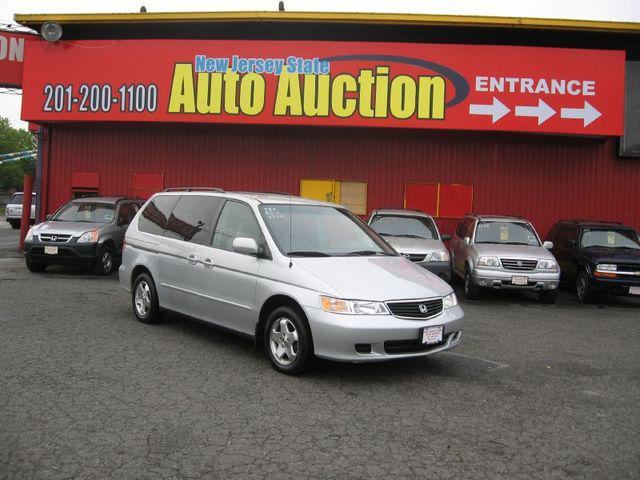How many cars would there be in the image now that one more car has been moved into the scene? Initially, there are four cars visible in the image. If we were to hypothetically move one more car into the scene, there would then be a total of five cars present. 